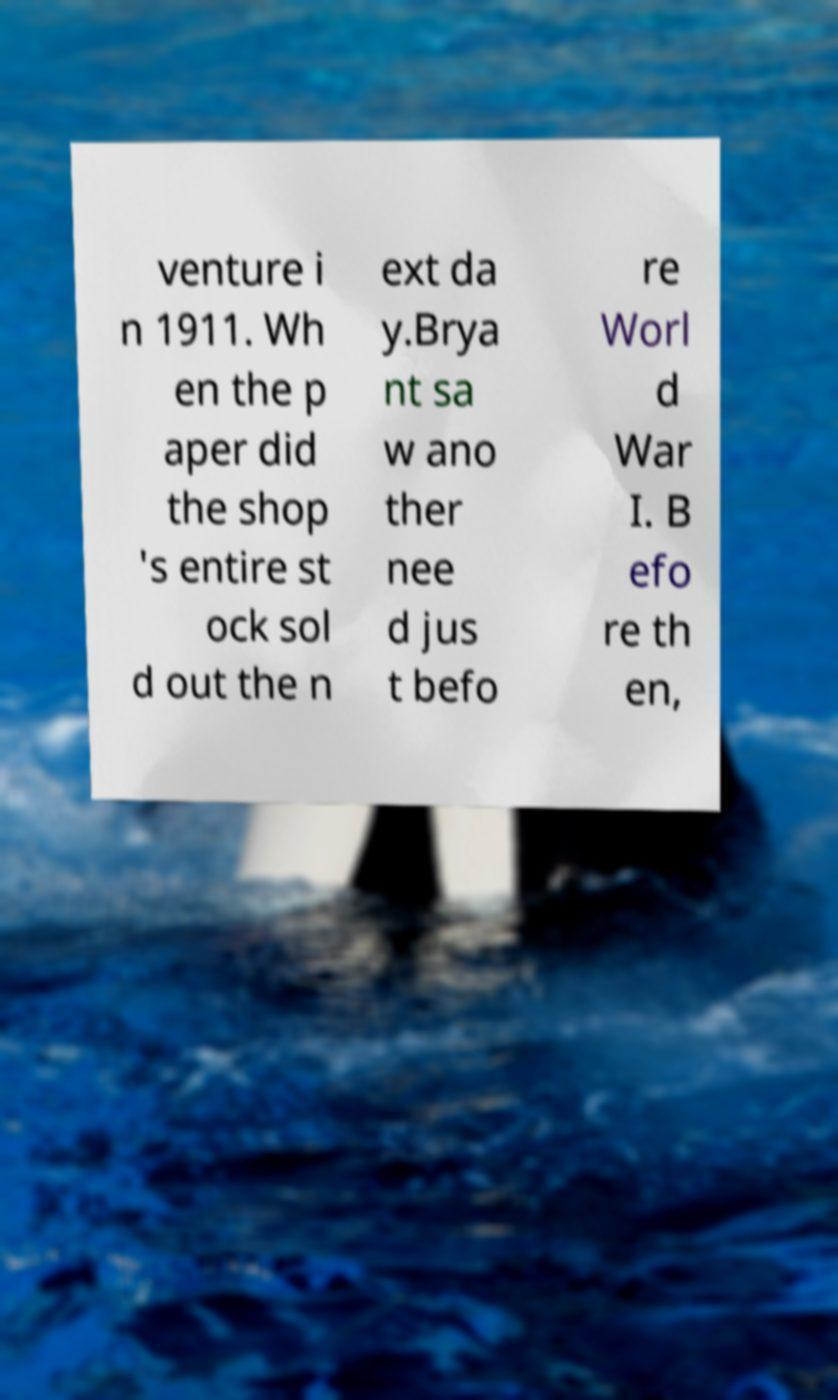For documentation purposes, I need the text within this image transcribed. Could you provide that? venture i n 1911. Wh en the p aper did the shop 's entire st ock sol d out the n ext da y.Brya nt sa w ano ther nee d jus t befo re Worl d War I. B efo re th en, 